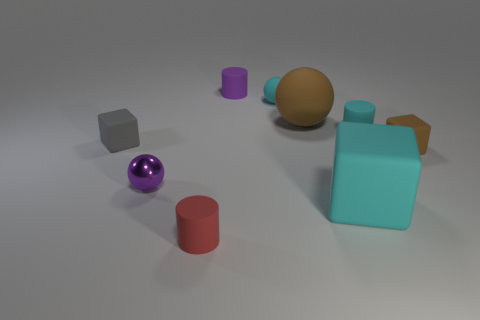Add 1 cyan matte balls. How many objects exist? 10 Subtract all blocks. How many objects are left? 6 Subtract 1 brown spheres. How many objects are left? 8 Subtract all blue matte cubes. Subtract all small metal objects. How many objects are left? 8 Add 2 purple metal spheres. How many purple metal spheres are left? 3 Add 7 rubber cubes. How many rubber cubes exist? 10 